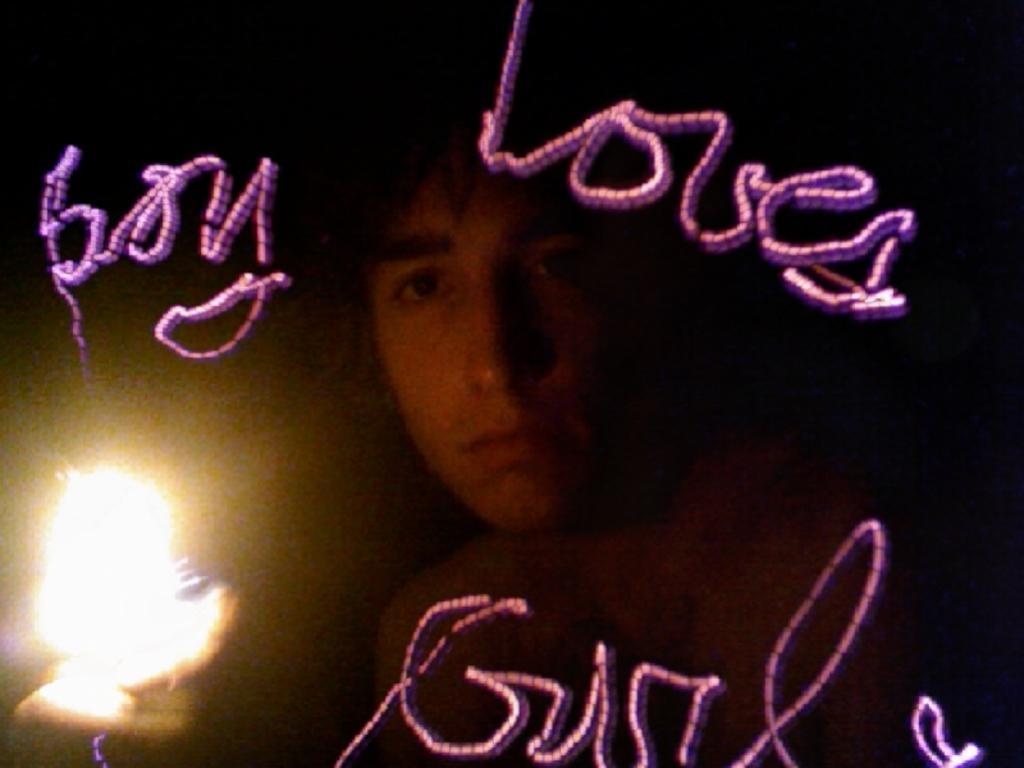How would you summarize this image in a sentence or two? In this image we can see one person, one light on the surface and some text on this picture. 